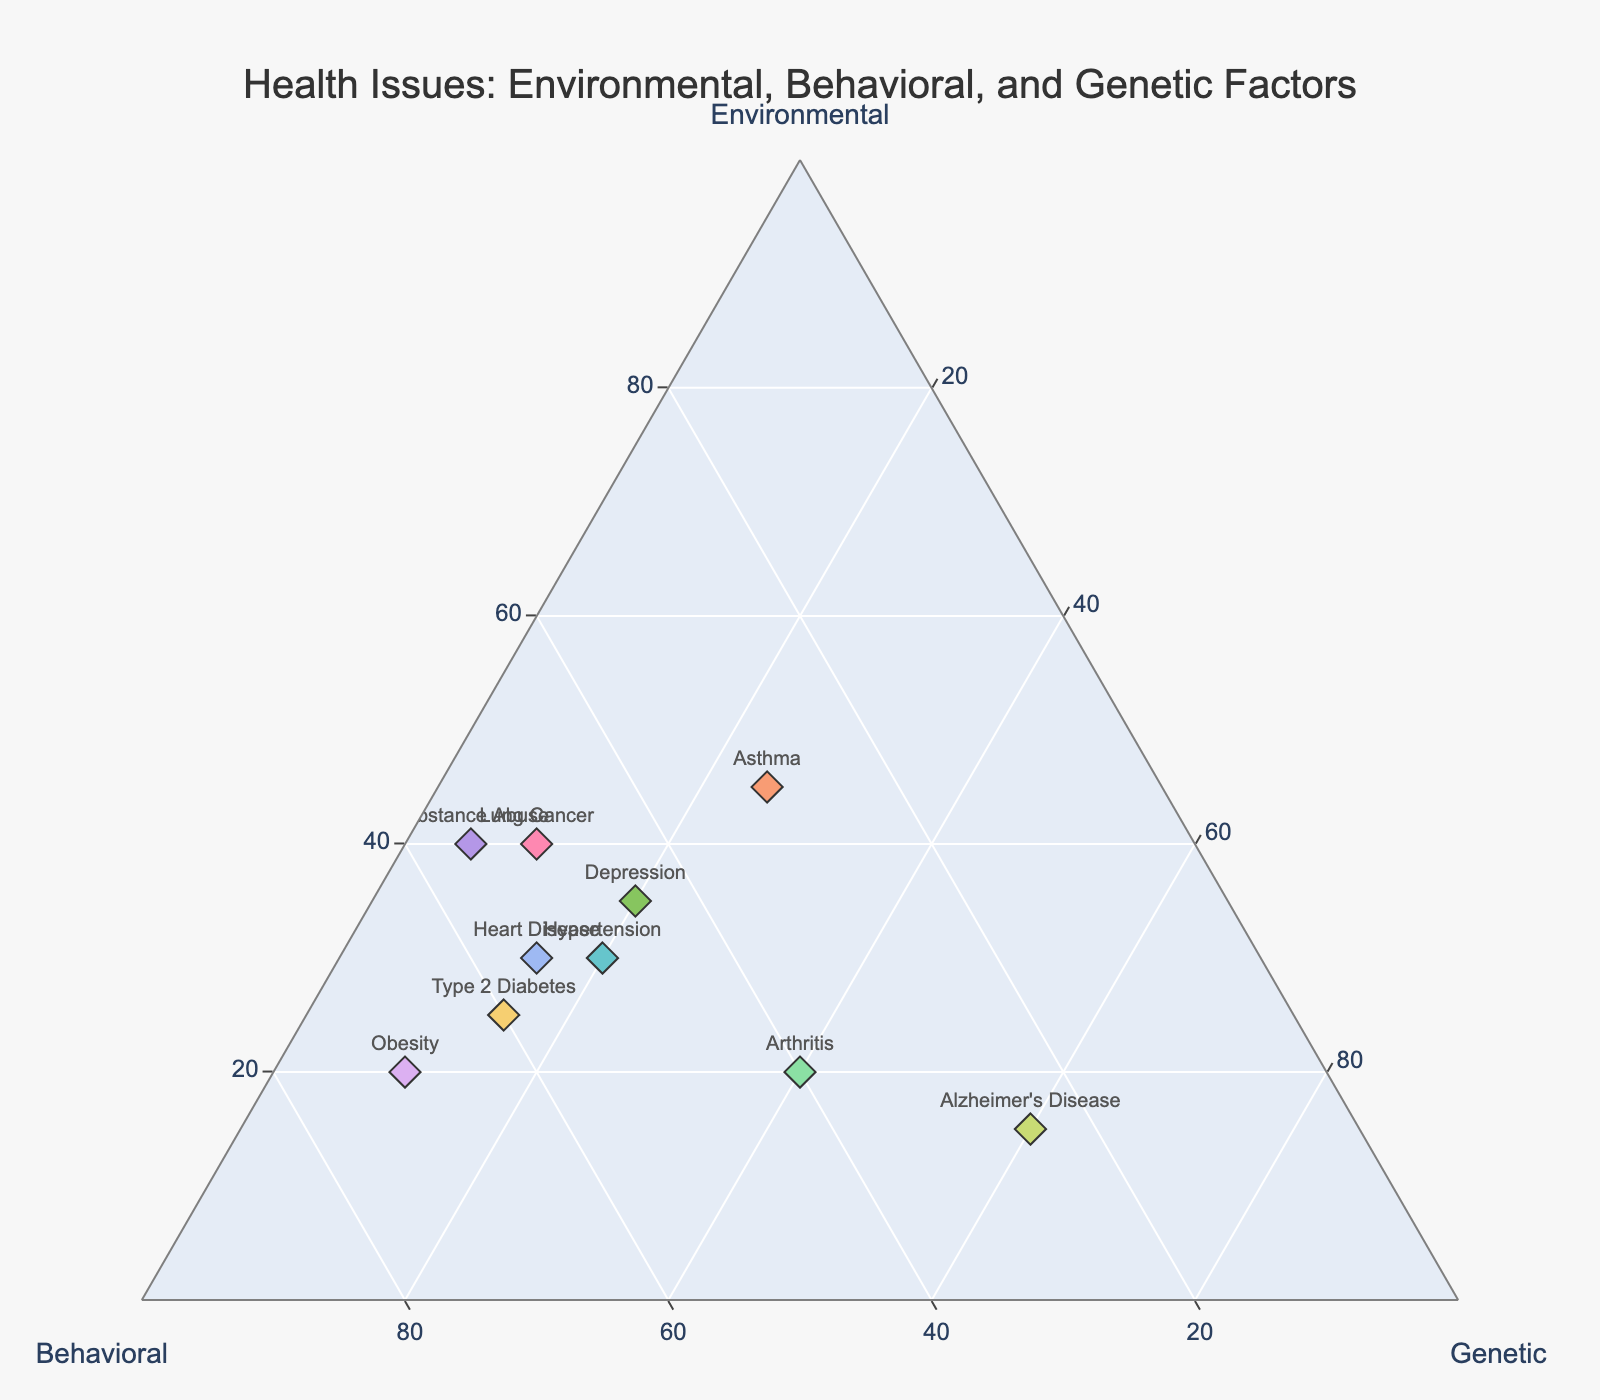What is the title of the plot? The title of the plot can be found at the top of the figure.
Answer: Health Issues: Environmental, Behavioral, and Genetic Factors How many health issues are represented in the plot? Count the total number of data points or labels in the figure.
Answer: 10 Which health issue has the highest genetic factor contribution? Look for the point with the highest value along the Genetic axis.
Answer: Alzheimer's Disease What is the combined proportion of environmental and behavioral factors for Hypertension? Add the Environmental proportion (30) to the Behavioral proportion (50).
Answer: 80 Which health issue has an equal contribution from behavioral and genetic factors? Identify the health issue where the points along the Behavioral and Genetic axes are equal.
Answer: Arthritis How does the contribution of environmental factors compare to behavioral factors for Obesity? Compare the numerical values along the Environmental axis (20) and the Behavioral axis (70).
Answer: Behavioral is greater than Environmental What is the average proportion of the genetic factor for all health issues? Sum all the Genetic proportions and divide by the number of health issues (20+15+25+10+20+15+10+60+40+5)/10.
Answer: 22 Which health issue has the most balanced proportions among environmental, behavioral, and genetic factors? Look for the data point where the values for Environmental, Behavioral, and Genetic are most similar.
Answer: Arthritis Is there any health issue with a genetic factor contribution higher than 50%? Check the Genetic axis for any value greater than 50.
Answer: Yes, Alzheimer's Disease Which health issue has the lowest environmental factor contribution? Look for the lowest value along the Environmental axis.
Answer: Alzheimer's Disease 